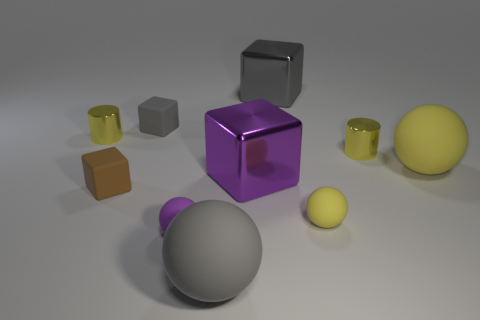There is a yellow rubber ball that is behind the brown rubber object; is its size the same as the shiny thing that is to the left of the small purple thing?
Keep it short and to the point. No. Does the large yellow object have the same material as the small cylinder that is right of the brown object?
Make the answer very short. No. Are there more purple spheres that are on the left side of the purple matte object than big yellow balls that are behind the large gray cube?
Provide a succinct answer. No. What color is the large cube that is behind the small metallic object that is to the left of the large purple block?
Provide a succinct answer. Gray. What number of balls are either brown things or tiny yellow matte objects?
Your response must be concise. 1. How many rubber things are on the left side of the tiny yellow rubber ball and in front of the purple shiny thing?
Offer a terse response. 3. There is a rubber sphere that is behind the small yellow ball; what color is it?
Provide a short and direct response. Yellow. There is another yellow ball that is made of the same material as the small yellow ball; what is its size?
Provide a succinct answer. Large. How many large purple metallic blocks are right of the tiny shiny object left of the big gray rubber object?
Offer a terse response. 1. What number of gray rubber spheres are to the right of the small yellow matte object?
Your answer should be compact. 0. 